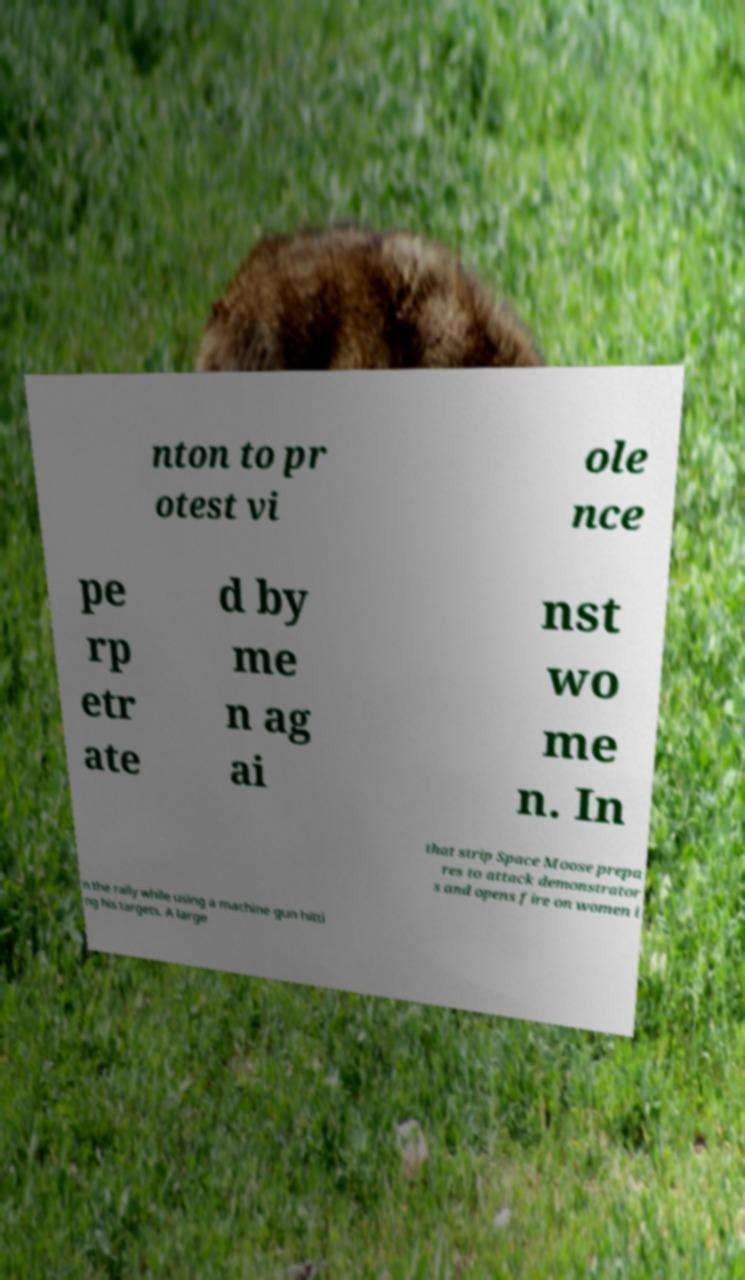For documentation purposes, I need the text within this image transcribed. Could you provide that? nton to pr otest vi ole nce pe rp etr ate d by me n ag ai nst wo me n. In that strip Space Moose prepa res to attack demonstrator s and opens fire on women i n the rally while using a machine gun hitti ng his targets. A large 